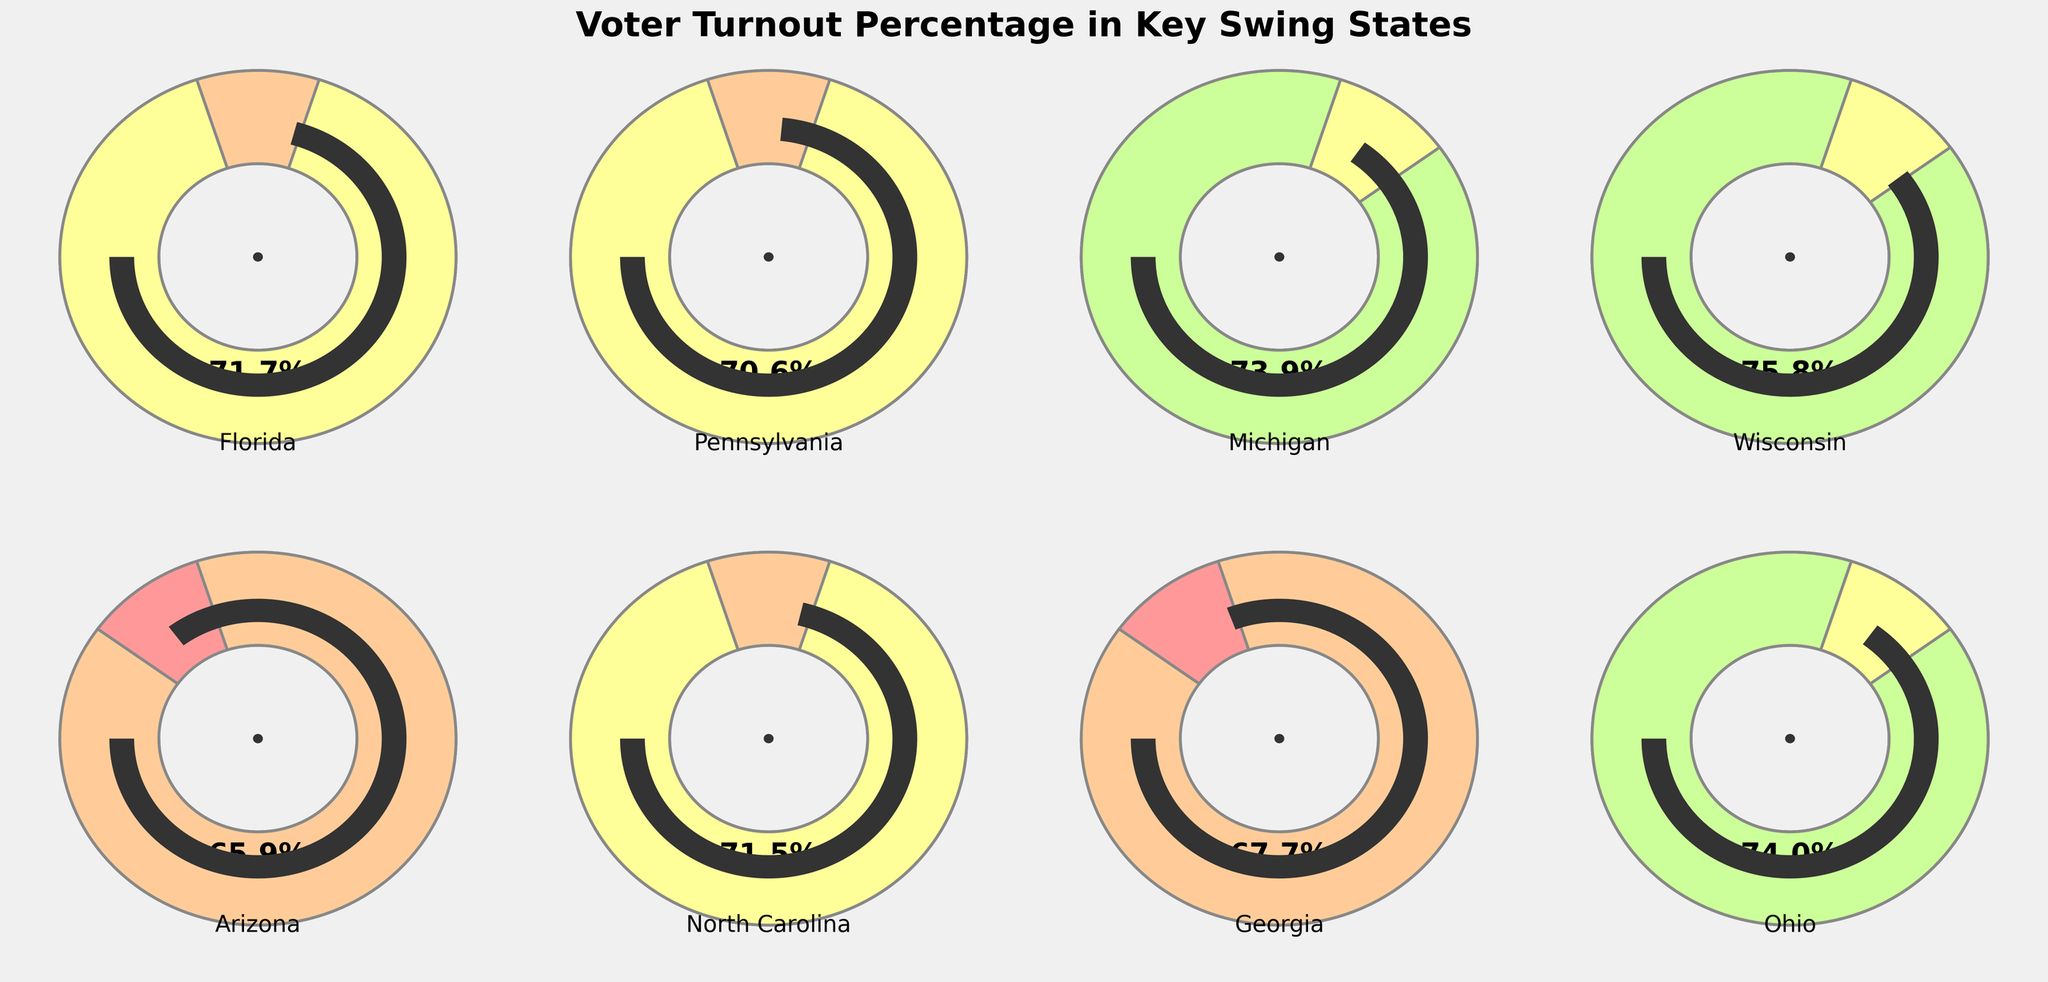Which state has the highest voter turnout percentage? The chart indicates the voter turnout percentages for each state using gauge visuals. By comparing all gauges, Wisconsin shows the highest turnout percentage.
Answer: Wisconsin How many states have a voter turnout percentage above 70%? By examining the gauges, we note that Florida, Pennsylvania, Michigan, Wisconsin, North Carolina, and Ohio all surpass 70%.
Answer: 6 What is the average voter turnout percentage across all states? Sum all the percentages: 71.7 (FL) + 70.6 (PA) + 73.9 (MI) + 75.8 (WI) + 65.9 (AZ) + 71.5 (NC) + 67.7 (GA) + 74.0 (OH) = 571.1. Then, divide by the number of states (8). 571.1 / 8 = 71.39
Answer: 71.39 Which state has the lowest voter turnout percentage? By observing all gauges, Arizona has the lowest percentage at 65.9%.
Answer: Arizona Compare the voter turnout percentages in Florida and Georgia. Which state had a higher turnout, and by how much? From the gauges, Florida's turnout is 71.7% and Georgia's is 67.7%. The difference is 71.7 - 67.7 = 4.0%.
Answer: Florida by 4.0% What is the difference in voter turnout percentage between Michigan and North Carolina? Michigan's turnout is 73.9%, while North Carolina's is 71.5%. The difference is 73.9 - 71.5 = 2.4%.
Answer: 2.4% Is the voter turnout percentage of Ohio higher than Pennsylvania? Comparing the gauges, Ohio's turnout (74.0%) is indeed higher than Pennsylvania's (70.6%).
Answer: Yes What is the combined voter turnout percentage of Wisconsin and Ohio? Add Wisconsin's turnout (75.8%) and Ohio's turnout (74.0%). 75.8 + 74.0 = 149.8%.
Answer: 149.8% Which states have a voter turnout percentage between 70% and 75% inclusively? The states that fit this range are Florida (71.7%), Pennsylvania (70.6%), Michigan (73.9%), North Carolina (71.5%), and Ohio (74.0%).
Answer: Florida, Pennsylvania, Michigan, North Carolina, Ohio 